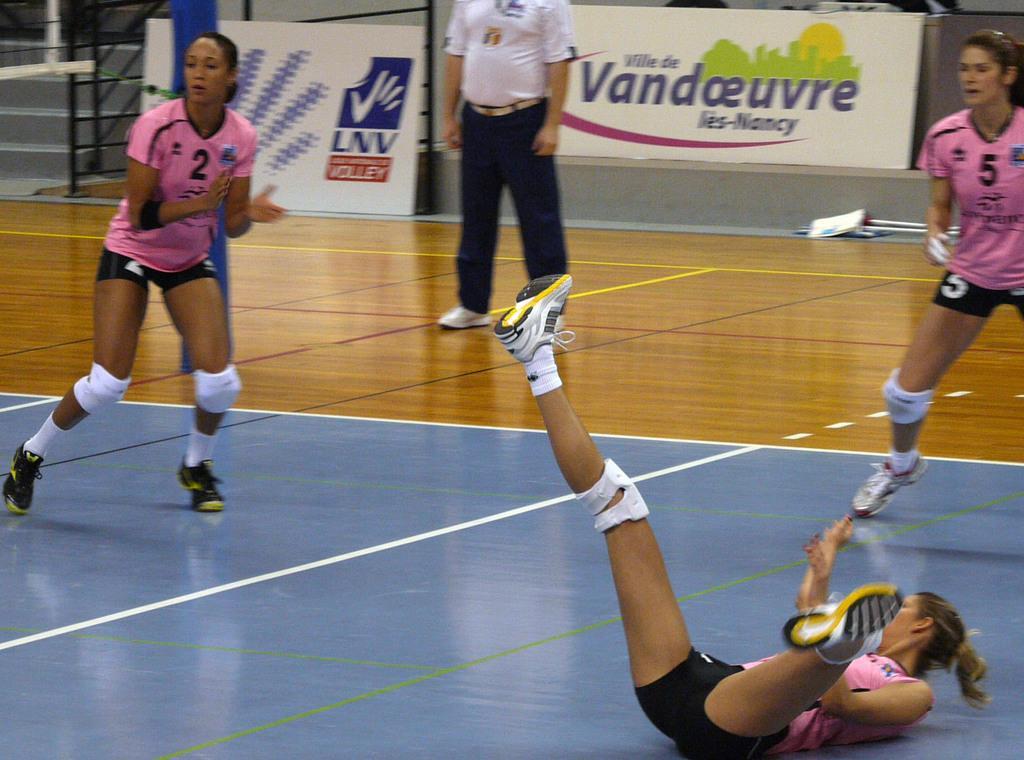Please provide a concise description of this image. In this image, we can see four persons. Few people are playing a game on the surface. Background we can see grills, banners, stairs and few objects. 